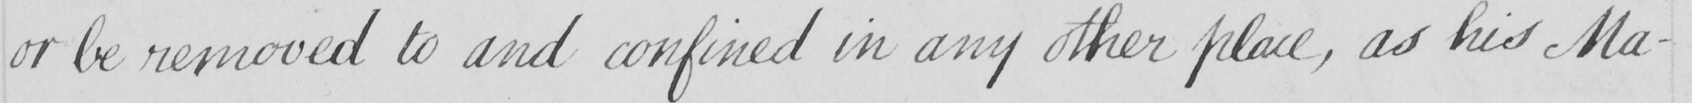Please provide the text content of this handwritten line. or be removed to and confined in any other place , as his Ma- 